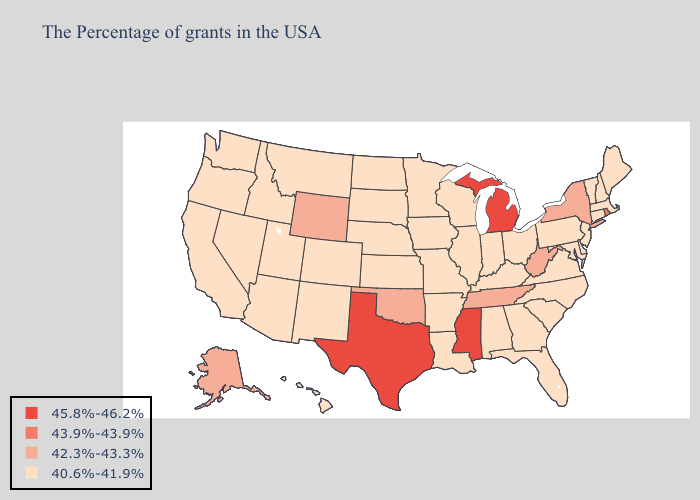Name the states that have a value in the range 43.9%-43.9%?
Quick response, please. Rhode Island. What is the highest value in states that border Alabama?
Be succinct. 45.8%-46.2%. Name the states that have a value in the range 45.8%-46.2%?
Concise answer only. Michigan, Mississippi, Texas. What is the value of Iowa?
Write a very short answer. 40.6%-41.9%. Does Alaska have the lowest value in the USA?
Short answer required. No. Name the states that have a value in the range 42.3%-43.3%?
Write a very short answer. New York, West Virginia, Tennessee, Oklahoma, Wyoming, Alaska. Which states have the lowest value in the South?
Be succinct. Delaware, Maryland, Virginia, North Carolina, South Carolina, Florida, Georgia, Kentucky, Alabama, Louisiana, Arkansas. What is the value of North Dakota?
Keep it brief. 40.6%-41.9%. Which states have the highest value in the USA?
Give a very brief answer. Michigan, Mississippi, Texas. Which states hav the highest value in the West?
Be succinct. Wyoming, Alaska. Does Texas have the highest value in the USA?
Write a very short answer. Yes. Name the states that have a value in the range 45.8%-46.2%?
Concise answer only. Michigan, Mississippi, Texas. What is the highest value in the USA?
Short answer required. 45.8%-46.2%. How many symbols are there in the legend?
Write a very short answer. 4. Name the states that have a value in the range 43.9%-43.9%?
Keep it brief. Rhode Island. 